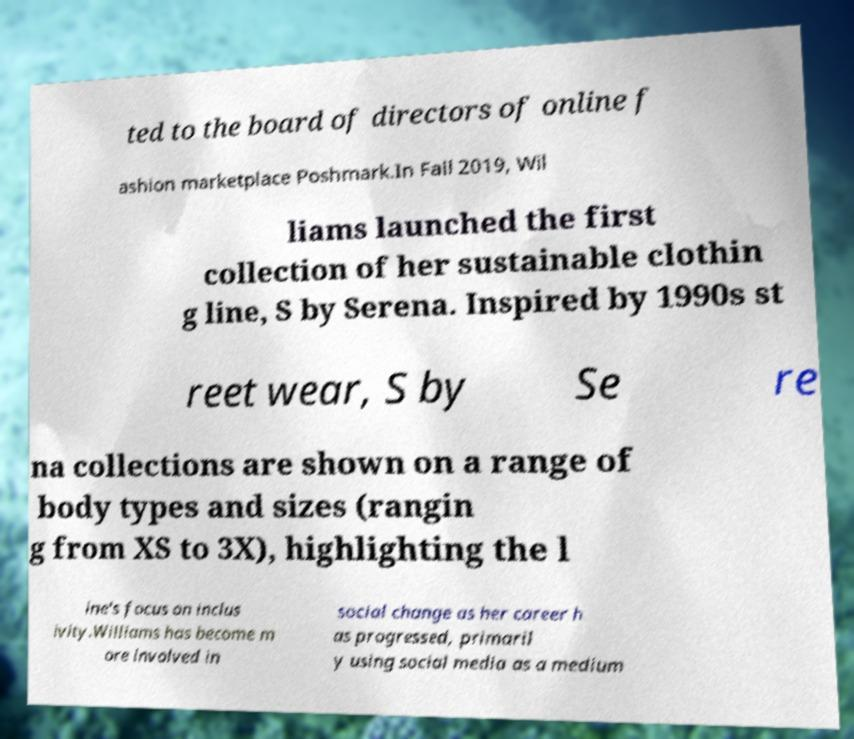Please read and relay the text visible in this image. What does it say? ted to the board of directors of online f ashion marketplace Poshmark.In Fall 2019, Wil liams launched the first collection of her sustainable clothin g line, S by Serena. Inspired by 1990s st reet wear, S by Se re na collections are shown on a range of body types and sizes (rangin g from XS to 3X), highlighting the l ine's focus on inclus ivity.Williams has become m ore involved in social change as her career h as progressed, primaril y using social media as a medium 